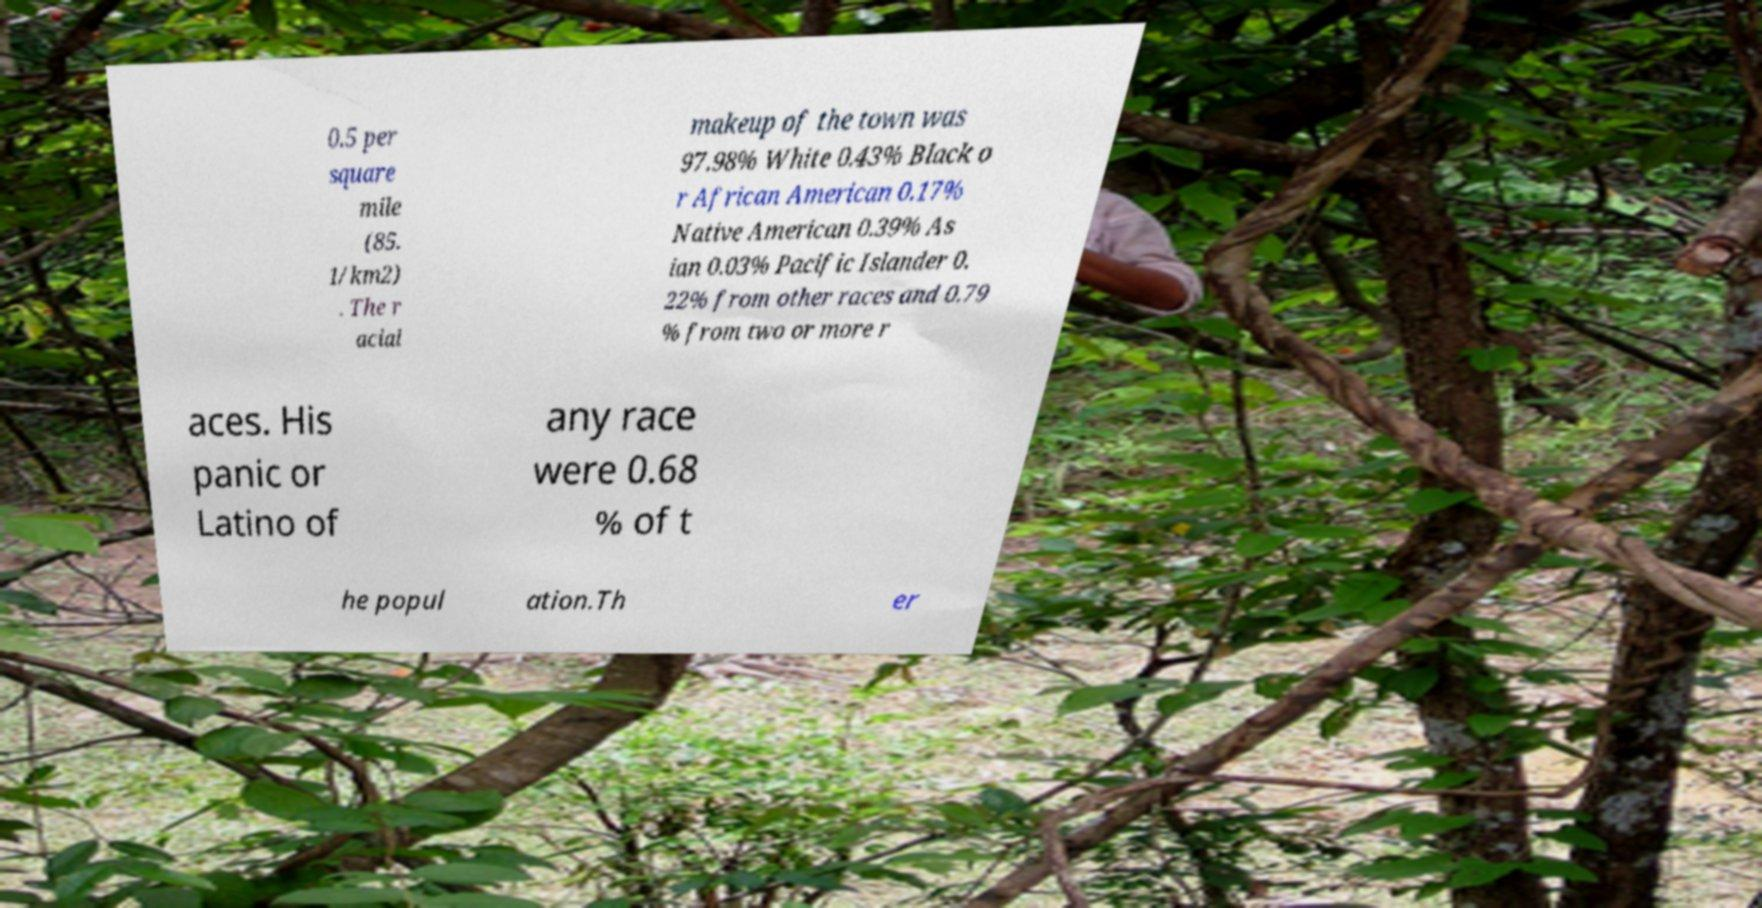Please read and relay the text visible in this image. What does it say? 0.5 per square mile (85. 1/km2) . The r acial makeup of the town was 97.98% White 0.43% Black o r African American 0.17% Native American 0.39% As ian 0.03% Pacific Islander 0. 22% from other races and 0.79 % from two or more r aces. His panic or Latino of any race were 0.68 % of t he popul ation.Th er 